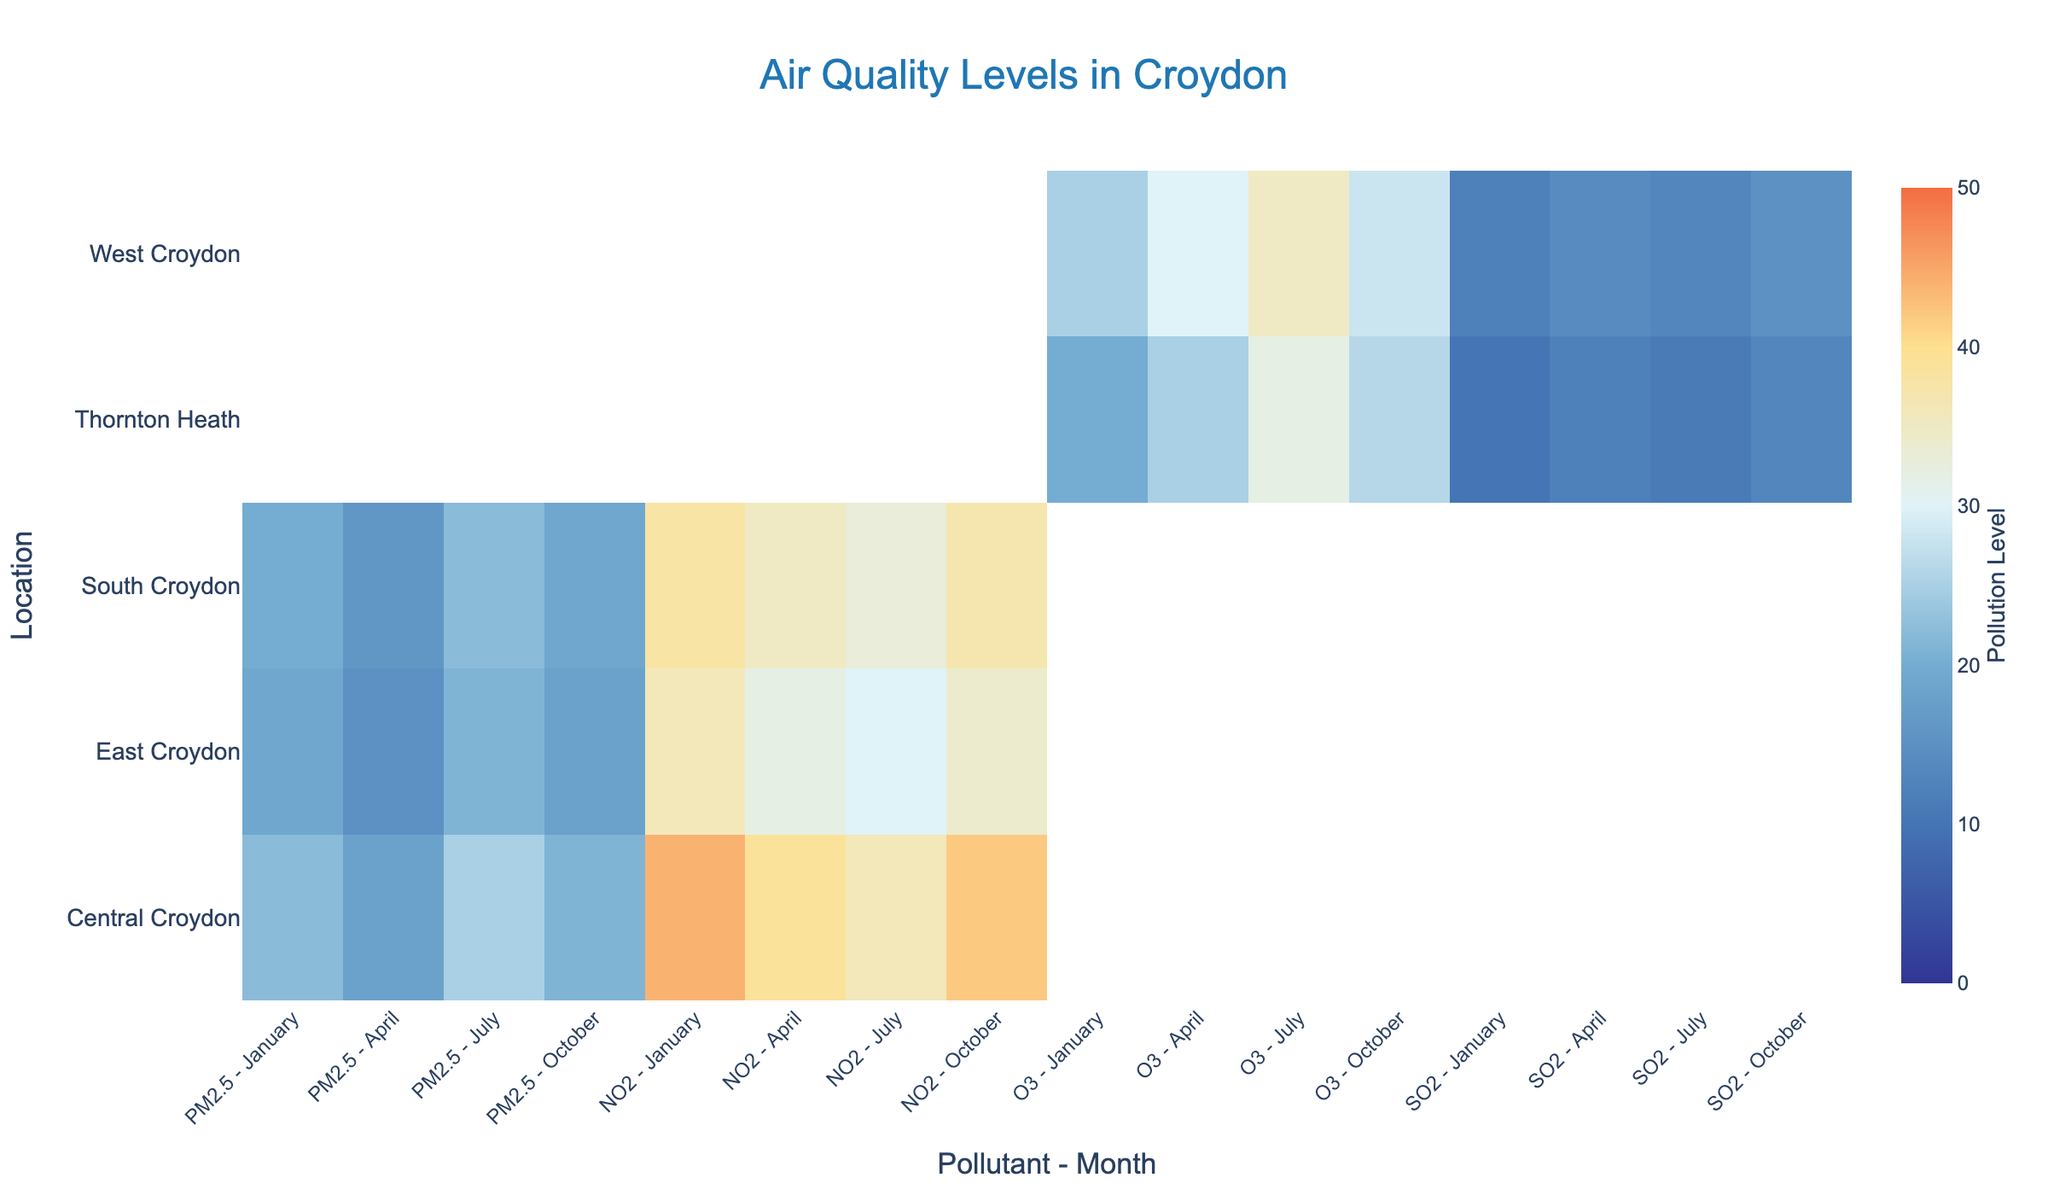Who has the highest PM2.5 levels in July? Look at the column for PM2.5 in July and find the location with the highest value. Central Croydon has the highest value at 25.
Answer: Central Croydon How do NO2 levels in Central Croydon compare between January and July? Check the NO2 levels for Central Croydon in January and July. In January, it's 44, and in July, it's 36. January has higher levels than July.
Answer: January > July What is the average SO2 level across all months in Thornton Heath? Sum SO2 levels in Thornton Heath across all months (10 + 12 + 11 + 13) and divide by the number of months (4). (10 + 12 + 11 + 13) / 4 = 11.5
Answer: 11.5 Which pollutant has the highest variation in levels in West Croydon? Analyze the range of levels for O3 and SO2 in West Croydon. O3 ranges from 25 to 35 (range = 10), and SO2 ranges from 12 to 15 (range = 3). O3 has the higher variation.
Answer: O3 What is the total PM2.5 level for South Croydon across all months? Sum the PM2.5 levels in South Croydon across all months: 20 + 16 + 22 + 19 = 77.
Answer: 77 What can you say about the trend of NO2 levels in East Croydon throughout the year? Observe the NO2 levels in East Croydon: January (36), April (32), July (30), October (34). The levels generally decrease from January to July and then slightly increase in October.
Answer: Decreases then increases Compare the O3 levels between Thornton Heath and West Croydon in April. Which has higher levels? Check the O3 levels in April for both locations: Thornton Heath (25) and West Croydon (30). West Croydon has higher levels.
Answer: West Croydon What is the maximum air quality level recorded for PM2.5 in any location and month? Look at all PM2.5 levels in all locations and months. The maximum value is 25 in Central Croydon in July.
Answer: 25 Is there any month where the PM2.5 levels in East Croydon exceed 20? Check all the PM2.5 levels in East Croydon for each month: January (19), April (15), July (21), October (18). Only in July does the value exceed 20.
Answer: Yes, July What is the difference between the SO2 levels in West Croydon and Thornton Heath in October? Find SO2 levels for October in both locations: West Croydon (15) and Thornton Heath (13). Calculate the difference: 15 - 13 = 2.
Answer: 2 